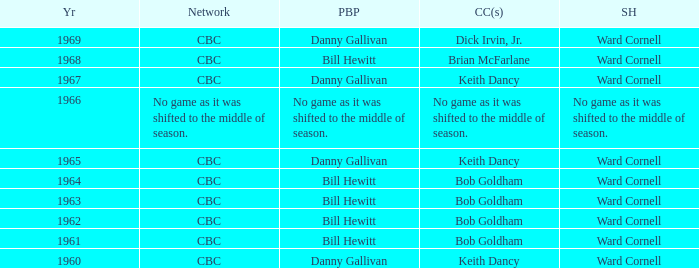Who did the play-by-play on the CBC network before 1961? Danny Gallivan. 